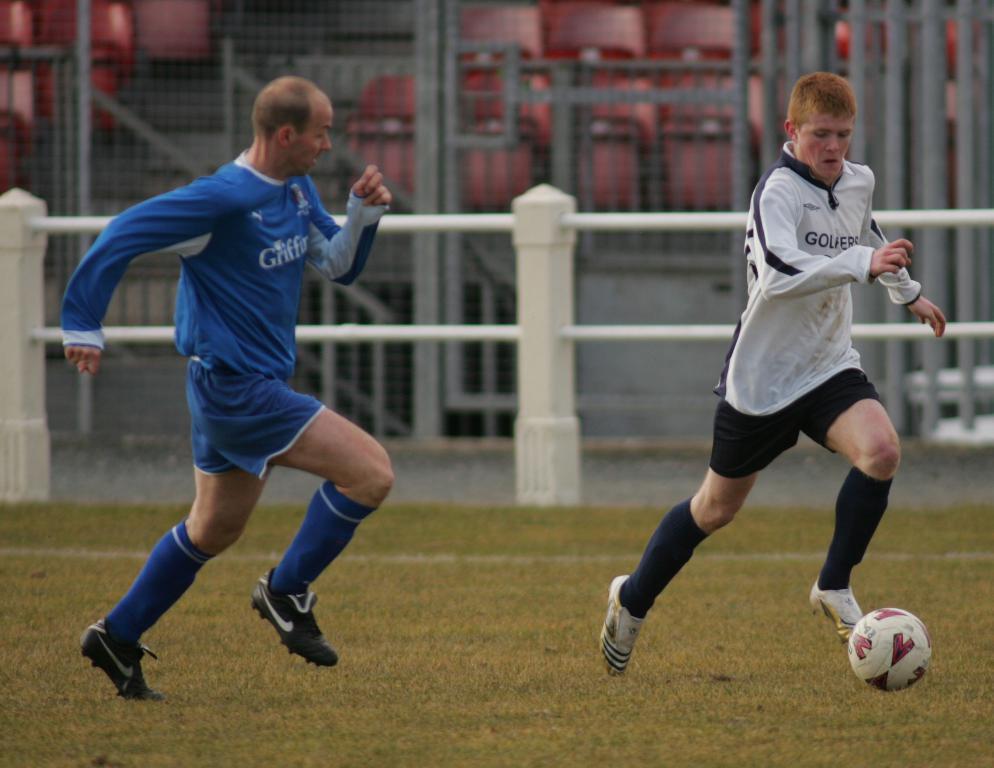Can you describe this image briefly? In this image we can see there are two persons playing on a ground. In the background there is a fencing with a net. 